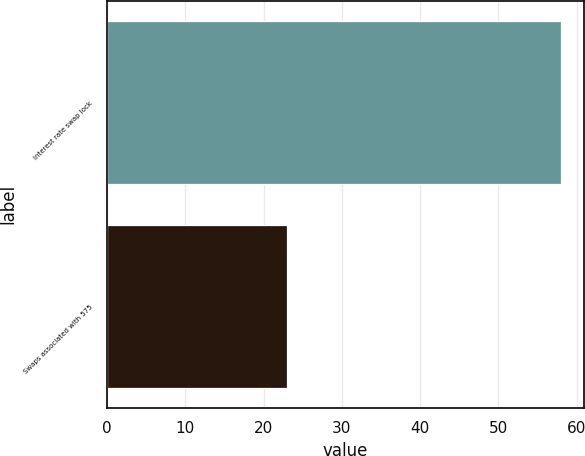Convert chart to OTSL. <chart><loc_0><loc_0><loc_500><loc_500><bar_chart><fcel>Interest rate swap lock<fcel>Swaps associated with 575<nl><fcel>58<fcel>23<nl></chart> 